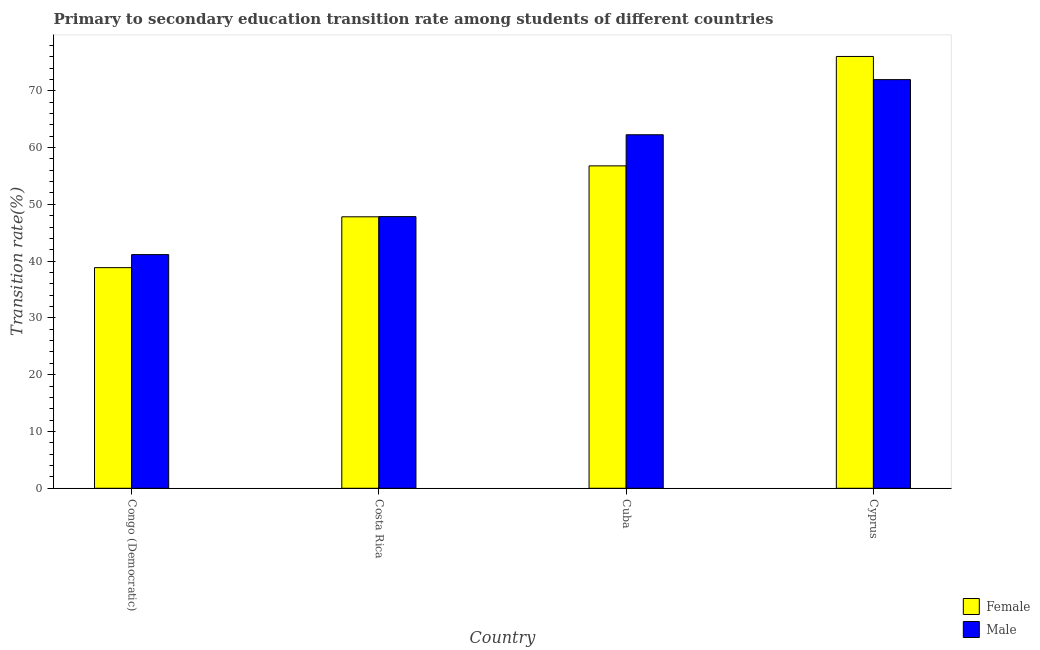How many different coloured bars are there?
Provide a succinct answer. 2. How many groups of bars are there?
Your answer should be compact. 4. Are the number of bars on each tick of the X-axis equal?
Keep it short and to the point. Yes. What is the label of the 3rd group of bars from the left?
Provide a short and direct response. Cuba. What is the transition rate among male students in Cyprus?
Your answer should be compact. 71.96. Across all countries, what is the maximum transition rate among male students?
Make the answer very short. 71.96. Across all countries, what is the minimum transition rate among female students?
Your response must be concise. 38.85. In which country was the transition rate among male students maximum?
Offer a very short reply. Cyprus. In which country was the transition rate among female students minimum?
Offer a very short reply. Congo (Democratic). What is the total transition rate among male students in the graph?
Give a very brief answer. 223.21. What is the difference between the transition rate among female students in Congo (Democratic) and that in Cyprus?
Provide a succinct answer. -37.19. What is the difference between the transition rate among male students in Cuba and the transition rate among female students in Costa Rica?
Offer a terse response. 14.45. What is the average transition rate among female students per country?
Your answer should be very brief. 54.87. What is the difference between the transition rate among male students and transition rate among female students in Cyprus?
Offer a terse response. -4.08. What is the ratio of the transition rate among male students in Cuba to that in Cyprus?
Provide a short and direct response. 0.87. Is the difference between the transition rate among female students in Congo (Democratic) and Costa Rica greater than the difference between the transition rate among male students in Congo (Democratic) and Costa Rica?
Make the answer very short. No. What is the difference between the highest and the second highest transition rate among female students?
Provide a succinct answer. 19.27. What is the difference between the highest and the lowest transition rate among female students?
Your answer should be compact. 37.19. In how many countries, is the transition rate among male students greater than the average transition rate among male students taken over all countries?
Your answer should be compact. 2. Is the sum of the transition rate among female students in Congo (Democratic) and Cuba greater than the maximum transition rate among male students across all countries?
Your response must be concise. Yes. What does the 2nd bar from the right in Congo (Democratic) represents?
Your answer should be very brief. Female. How many bars are there?
Offer a terse response. 8. What is the difference between two consecutive major ticks on the Y-axis?
Provide a succinct answer. 10. Are the values on the major ticks of Y-axis written in scientific E-notation?
Ensure brevity in your answer.  No. Does the graph contain any zero values?
Your answer should be compact. No. Where does the legend appear in the graph?
Provide a succinct answer. Bottom right. How are the legend labels stacked?
Ensure brevity in your answer.  Vertical. What is the title of the graph?
Ensure brevity in your answer.  Primary to secondary education transition rate among students of different countries. What is the label or title of the X-axis?
Give a very brief answer. Country. What is the label or title of the Y-axis?
Offer a terse response. Transition rate(%). What is the Transition rate(%) of Female in Congo (Democratic)?
Provide a short and direct response. 38.85. What is the Transition rate(%) of Male in Congo (Democratic)?
Ensure brevity in your answer.  41.15. What is the Transition rate(%) of Female in Costa Rica?
Your answer should be very brief. 47.81. What is the Transition rate(%) of Male in Costa Rica?
Your answer should be compact. 47.84. What is the Transition rate(%) in Female in Cuba?
Offer a very short reply. 56.78. What is the Transition rate(%) in Male in Cuba?
Make the answer very short. 62.26. What is the Transition rate(%) in Female in Cyprus?
Provide a short and direct response. 76.04. What is the Transition rate(%) in Male in Cyprus?
Keep it short and to the point. 71.96. Across all countries, what is the maximum Transition rate(%) in Female?
Offer a terse response. 76.04. Across all countries, what is the maximum Transition rate(%) in Male?
Give a very brief answer. 71.96. Across all countries, what is the minimum Transition rate(%) in Female?
Your response must be concise. 38.85. Across all countries, what is the minimum Transition rate(%) of Male?
Your answer should be compact. 41.15. What is the total Transition rate(%) in Female in the graph?
Your answer should be very brief. 219.48. What is the total Transition rate(%) in Male in the graph?
Offer a very short reply. 223.21. What is the difference between the Transition rate(%) of Female in Congo (Democratic) and that in Costa Rica?
Offer a very short reply. -8.95. What is the difference between the Transition rate(%) of Male in Congo (Democratic) and that in Costa Rica?
Ensure brevity in your answer.  -6.69. What is the difference between the Transition rate(%) in Female in Congo (Democratic) and that in Cuba?
Keep it short and to the point. -17.92. What is the difference between the Transition rate(%) of Male in Congo (Democratic) and that in Cuba?
Provide a succinct answer. -21.11. What is the difference between the Transition rate(%) of Female in Congo (Democratic) and that in Cyprus?
Give a very brief answer. -37.19. What is the difference between the Transition rate(%) in Male in Congo (Democratic) and that in Cyprus?
Provide a short and direct response. -30.82. What is the difference between the Transition rate(%) in Female in Costa Rica and that in Cuba?
Keep it short and to the point. -8.97. What is the difference between the Transition rate(%) in Male in Costa Rica and that in Cuba?
Keep it short and to the point. -14.42. What is the difference between the Transition rate(%) of Female in Costa Rica and that in Cyprus?
Give a very brief answer. -28.24. What is the difference between the Transition rate(%) in Male in Costa Rica and that in Cyprus?
Ensure brevity in your answer.  -24.12. What is the difference between the Transition rate(%) in Female in Cuba and that in Cyprus?
Provide a short and direct response. -19.27. What is the difference between the Transition rate(%) of Male in Cuba and that in Cyprus?
Give a very brief answer. -9.71. What is the difference between the Transition rate(%) in Female in Congo (Democratic) and the Transition rate(%) in Male in Costa Rica?
Give a very brief answer. -8.99. What is the difference between the Transition rate(%) of Female in Congo (Democratic) and the Transition rate(%) of Male in Cuba?
Your answer should be very brief. -23.4. What is the difference between the Transition rate(%) of Female in Congo (Democratic) and the Transition rate(%) of Male in Cyprus?
Provide a short and direct response. -33.11. What is the difference between the Transition rate(%) of Female in Costa Rica and the Transition rate(%) of Male in Cuba?
Your answer should be compact. -14.45. What is the difference between the Transition rate(%) in Female in Costa Rica and the Transition rate(%) in Male in Cyprus?
Offer a very short reply. -24.16. What is the difference between the Transition rate(%) of Female in Cuba and the Transition rate(%) of Male in Cyprus?
Your answer should be compact. -15.19. What is the average Transition rate(%) of Female per country?
Provide a short and direct response. 54.87. What is the average Transition rate(%) in Male per country?
Provide a short and direct response. 55.8. What is the difference between the Transition rate(%) of Female and Transition rate(%) of Male in Congo (Democratic)?
Give a very brief answer. -2.29. What is the difference between the Transition rate(%) of Female and Transition rate(%) of Male in Costa Rica?
Give a very brief answer. -0.03. What is the difference between the Transition rate(%) in Female and Transition rate(%) in Male in Cuba?
Provide a succinct answer. -5.48. What is the difference between the Transition rate(%) of Female and Transition rate(%) of Male in Cyprus?
Your response must be concise. 4.08. What is the ratio of the Transition rate(%) of Female in Congo (Democratic) to that in Costa Rica?
Make the answer very short. 0.81. What is the ratio of the Transition rate(%) of Male in Congo (Democratic) to that in Costa Rica?
Make the answer very short. 0.86. What is the ratio of the Transition rate(%) in Female in Congo (Democratic) to that in Cuba?
Ensure brevity in your answer.  0.68. What is the ratio of the Transition rate(%) of Male in Congo (Democratic) to that in Cuba?
Provide a succinct answer. 0.66. What is the ratio of the Transition rate(%) of Female in Congo (Democratic) to that in Cyprus?
Your answer should be very brief. 0.51. What is the ratio of the Transition rate(%) in Male in Congo (Democratic) to that in Cyprus?
Ensure brevity in your answer.  0.57. What is the ratio of the Transition rate(%) of Female in Costa Rica to that in Cuba?
Ensure brevity in your answer.  0.84. What is the ratio of the Transition rate(%) in Male in Costa Rica to that in Cuba?
Give a very brief answer. 0.77. What is the ratio of the Transition rate(%) in Female in Costa Rica to that in Cyprus?
Give a very brief answer. 0.63. What is the ratio of the Transition rate(%) in Male in Costa Rica to that in Cyprus?
Provide a succinct answer. 0.66. What is the ratio of the Transition rate(%) in Female in Cuba to that in Cyprus?
Provide a short and direct response. 0.75. What is the ratio of the Transition rate(%) in Male in Cuba to that in Cyprus?
Ensure brevity in your answer.  0.87. What is the difference between the highest and the second highest Transition rate(%) of Female?
Provide a short and direct response. 19.27. What is the difference between the highest and the second highest Transition rate(%) in Male?
Ensure brevity in your answer.  9.71. What is the difference between the highest and the lowest Transition rate(%) in Female?
Your answer should be compact. 37.19. What is the difference between the highest and the lowest Transition rate(%) of Male?
Keep it short and to the point. 30.82. 